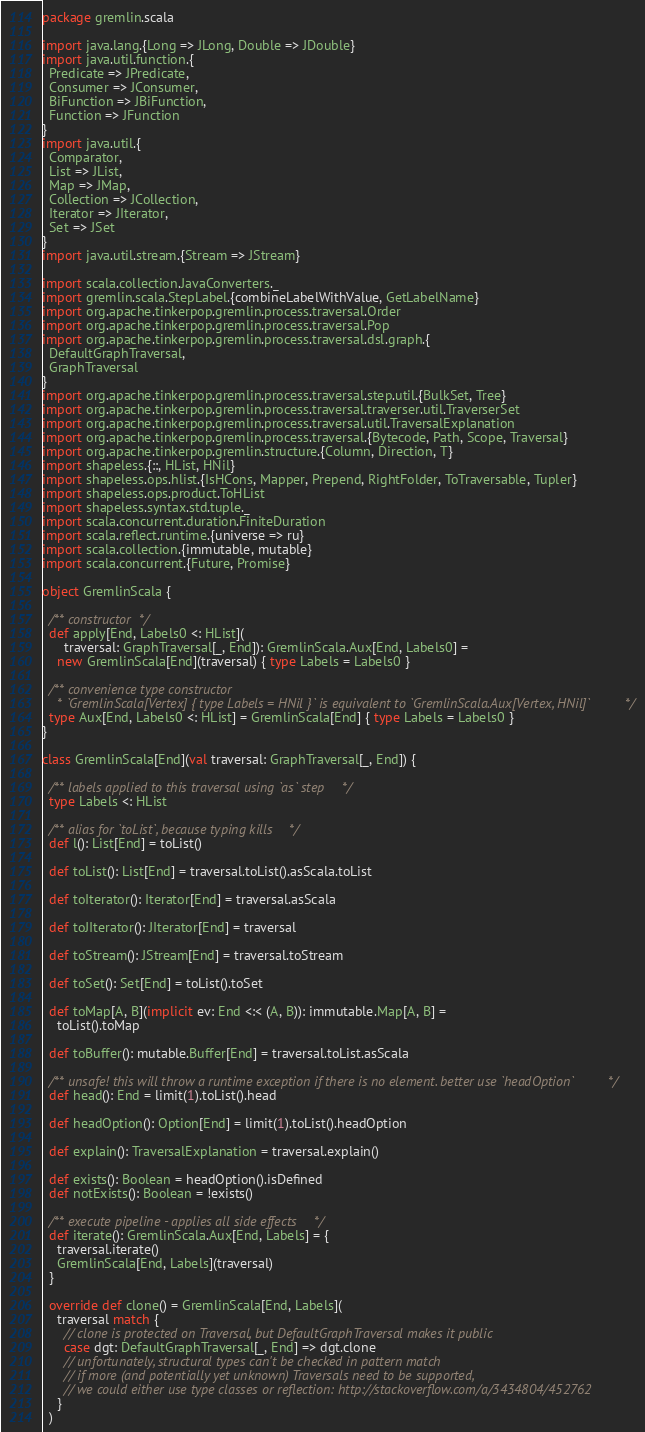Convert code to text. <code><loc_0><loc_0><loc_500><loc_500><_Scala_>package gremlin.scala

import java.lang.{Long => JLong, Double => JDouble}
import java.util.function.{
  Predicate => JPredicate,
  Consumer => JConsumer,
  BiFunction => JBiFunction,
  Function => JFunction
}
import java.util.{
  Comparator,
  List => JList,
  Map => JMap,
  Collection => JCollection,
  Iterator => JIterator,
  Set => JSet
}
import java.util.stream.{Stream => JStream}

import scala.collection.JavaConverters._
import gremlin.scala.StepLabel.{combineLabelWithValue, GetLabelName}
import org.apache.tinkerpop.gremlin.process.traversal.Order
import org.apache.tinkerpop.gremlin.process.traversal.Pop
import org.apache.tinkerpop.gremlin.process.traversal.dsl.graph.{
  DefaultGraphTraversal,
  GraphTraversal
}
import org.apache.tinkerpop.gremlin.process.traversal.step.util.{BulkSet, Tree}
import org.apache.tinkerpop.gremlin.process.traversal.traverser.util.TraverserSet
import org.apache.tinkerpop.gremlin.process.traversal.util.TraversalExplanation
import org.apache.tinkerpop.gremlin.process.traversal.{Bytecode, Path, Scope, Traversal}
import org.apache.tinkerpop.gremlin.structure.{Column, Direction, T}
import shapeless.{::, HList, HNil}
import shapeless.ops.hlist.{IsHCons, Mapper, Prepend, RightFolder, ToTraversable, Tupler}
import shapeless.ops.product.ToHList
import shapeless.syntax.std.tuple._
import scala.concurrent.duration.FiniteDuration
import scala.reflect.runtime.{universe => ru}
import scala.collection.{immutable, mutable}
import scala.concurrent.{Future, Promise}

object GremlinScala {

  /** constructor */
  def apply[End, Labels0 <: HList](
      traversal: GraphTraversal[_, End]): GremlinScala.Aux[End, Labels0] =
    new GremlinScala[End](traversal) { type Labels = Labels0 }

  /** convenience type constructor
    * `GremlinScala[Vertex] { type Labels = HNil }` is equivalent to `GremlinScala.Aux[Vertex, HNil]` */
  type Aux[End, Labels0 <: HList] = GremlinScala[End] { type Labels = Labels0 }
}

class GremlinScala[End](val traversal: GraphTraversal[_, End]) {

  /** labels applied to this traversal using `as` step */
  type Labels <: HList

  /** alias for `toList`, because typing kills */
  def l(): List[End] = toList()

  def toList(): List[End] = traversal.toList().asScala.toList

  def toIterator(): Iterator[End] = traversal.asScala

  def toJIterator(): JIterator[End] = traversal

  def toStream(): JStream[End] = traversal.toStream

  def toSet(): Set[End] = toList().toSet

  def toMap[A, B](implicit ev: End <:< (A, B)): immutable.Map[A, B] =
    toList().toMap

  def toBuffer(): mutable.Buffer[End] = traversal.toList.asScala

  /** unsafe! this will throw a runtime exception if there is no element. better use `headOption` */
  def head(): End = limit(1).toList().head

  def headOption(): Option[End] = limit(1).toList().headOption

  def explain(): TraversalExplanation = traversal.explain()

  def exists(): Boolean = headOption().isDefined
  def notExists(): Boolean = !exists()

  /** execute pipeline - applies all side effects */
  def iterate(): GremlinScala.Aux[End, Labels] = {
    traversal.iterate()
    GremlinScala[End, Labels](traversal)
  }

  override def clone() = GremlinScala[End, Labels](
    traversal match {
      // clone is protected on Traversal, but DefaultGraphTraversal makes it public
      case dgt: DefaultGraphTraversal[_, End] => dgt.clone
      // unfortunately, structural types can't be checked in pattern match
      // if more (and potentially yet unknown) Traversals need to be supported,
      // we could either use type classes or reflection: http://stackoverflow.com/a/3434804/452762
    }
  )
</code> 